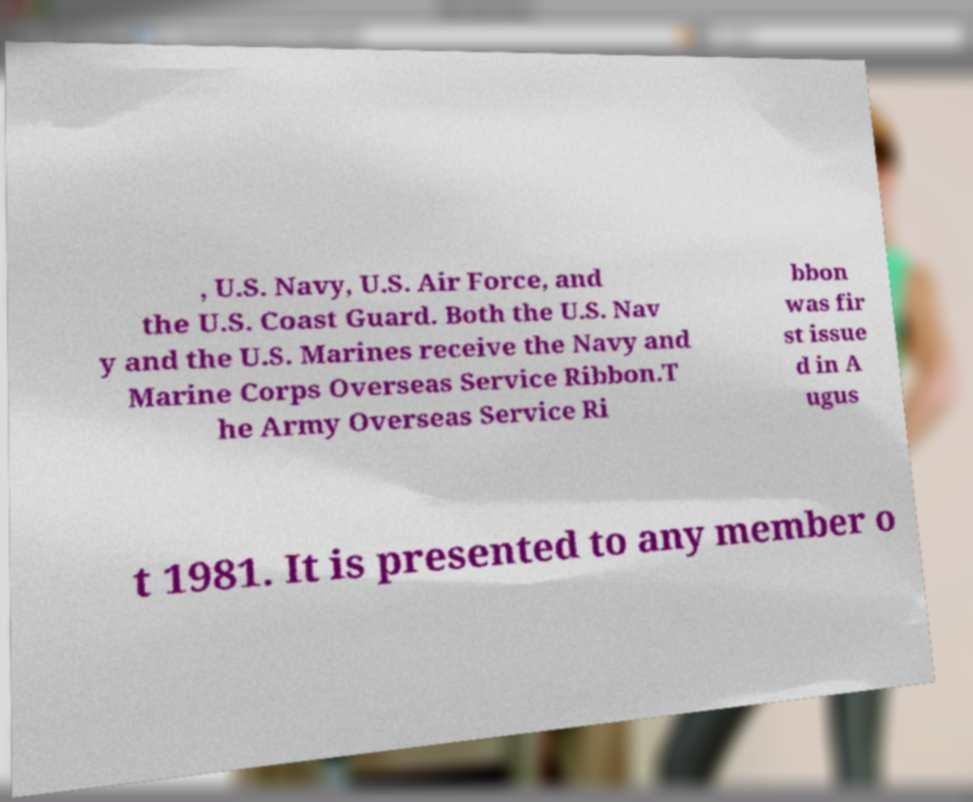For documentation purposes, I need the text within this image transcribed. Could you provide that? , U.S. Navy, U.S. Air Force, and the U.S. Coast Guard. Both the U.S. Nav y and the U.S. Marines receive the Navy and Marine Corps Overseas Service Ribbon.T he Army Overseas Service Ri bbon was fir st issue d in A ugus t 1981. It is presented to any member o 